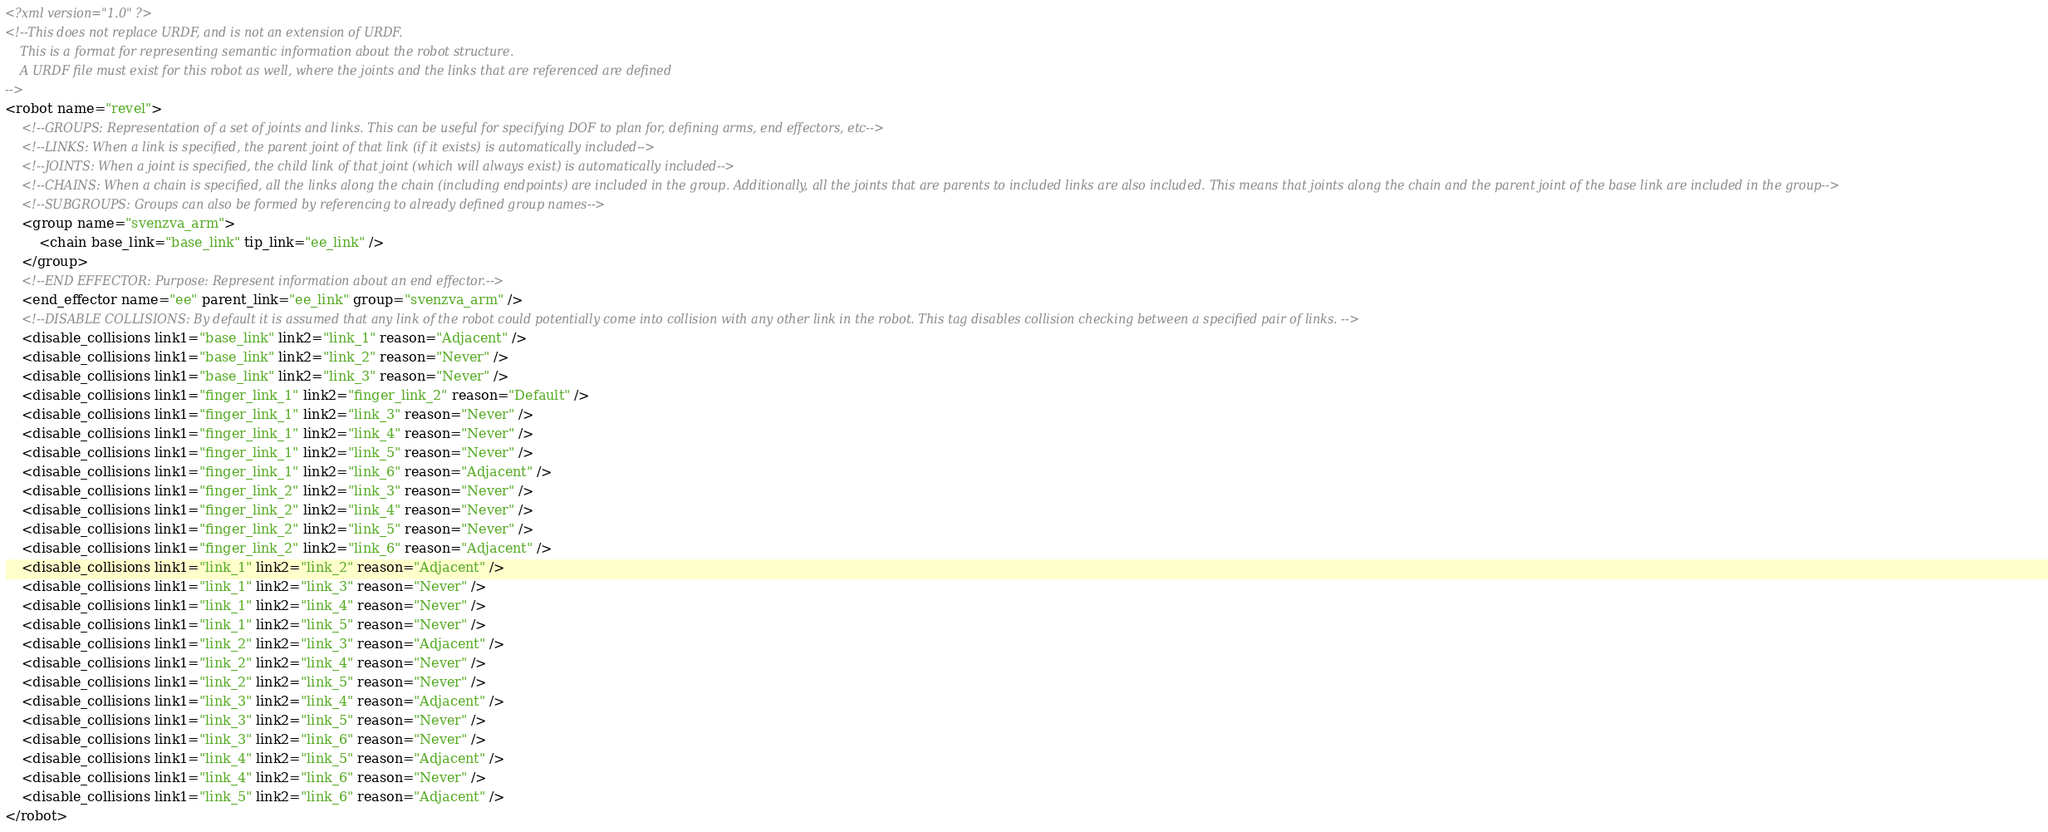<code> <loc_0><loc_0><loc_500><loc_500><_XML_><?xml version="1.0" ?>
<!--This does not replace URDF, and is not an extension of URDF.
    This is a format for representing semantic information about the robot structure.
    A URDF file must exist for this robot as well, where the joints and the links that are referenced are defined
-->
<robot name="revel">
    <!--GROUPS: Representation of a set of joints and links. This can be useful for specifying DOF to plan for, defining arms, end effectors, etc-->
    <!--LINKS: When a link is specified, the parent joint of that link (if it exists) is automatically included-->
    <!--JOINTS: When a joint is specified, the child link of that joint (which will always exist) is automatically included-->
    <!--CHAINS: When a chain is specified, all the links along the chain (including endpoints) are included in the group. Additionally, all the joints that are parents to included links are also included. This means that joints along the chain and the parent joint of the base link are included in the group-->
    <!--SUBGROUPS: Groups can also be formed by referencing to already defined group names-->
    <group name="svenzva_arm">
        <chain base_link="base_link" tip_link="ee_link" />
    </group>
    <!--END EFFECTOR: Purpose: Represent information about an end effector.-->
    <end_effector name="ee" parent_link="ee_link" group="svenzva_arm" />
    <!--DISABLE COLLISIONS: By default it is assumed that any link of the robot could potentially come into collision with any other link in the robot. This tag disables collision checking between a specified pair of links. -->
    <disable_collisions link1="base_link" link2="link_1" reason="Adjacent" />
    <disable_collisions link1="base_link" link2="link_2" reason="Never" />
    <disable_collisions link1="base_link" link2="link_3" reason="Never" />
    <disable_collisions link1="finger_link_1" link2="finger_link_2" reason="Default" />
    <disable_collisions link1="finger_link_1" link2="link_3" reason="Never" />
    <disable_collisions link1="finger_link_1" link2="link_4" reason="Never" />
    <disable_collisions link1="finger_link_1" link2="link_5" reason="Never" />
    <disable_collisions link1="finger_link_1" link2="link_6" reason="Adjacent" />
    <disable_collisions link1="finger_link_2" link2="link_3" reason="Never" />
    <disable_collisions link1="finger_link_2" link2="link_4" reason="Never" />
    <disable_collisions link1="finger_link_2" link2="link_5" reason="Never" />
    <disable_collisions link1="finger_link_2" link2="link_6" reason="Adjacent" />
    <disable_collisions link1="link_1" link2="link_2" reason="Adjacent" />
    <disable_collisions link1="link_1" link2="link_3" reason="Never" />
    <disable_collisions link1="link_1" link2="link_4" reason="Never" />
    <disable_collisions link1="link_1" link2="link_5" reason="Never" />
    <disable_collisions link1="link_2" link2="link_3" reason="Adjacent" />
    <disable_collisions link1="link_2" link2="link_4" reason="Never" />
    <disable_collisions link1="link_2" link2="link_5" reason="Never" />
    <disable_collisions link1="link_3" link2="link_4" reason="Adjacent" />
    <disable_collisions link1="link_3" link2="link_5" reason="Never" />
    <disable_collisions link1="link_3" link2="link_6" reason="Never" />
    <disable_collisions link1="link_4" link2="link_5" reason="Adjacent" />
    <disable_collisions link1="link_4" link2="link_6" reason="Never" />
    <disable_collisions link1="link_5" link2="link_6" reason="Adjacent" />
</robot>
</code> 